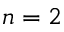Convert formula to latex. <formula><loc_0><loc_0><loc_500><loc_500>n = 2</formula> 